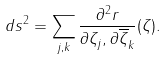<formula> <loc_0><loc_0><loc_500><loc_500>d s ^ { 2 } = \sum _ { j , k } \frac { \partial ^ { 2 } r } { \partial \zeta _ { j } , \partial \overline { \zeta } _ { k } } ( \zeta ) .</formula> 